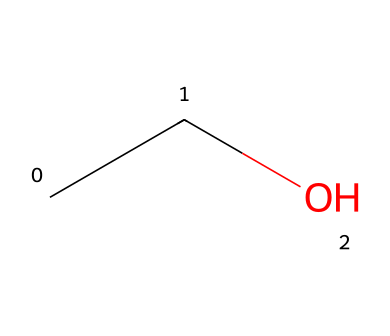What is the chemical name of the structure represented? The SMILES representation "CCO" indicates the presence of a two-carbon chain and a hydroxyl group, which defines the structure as ethanol.
Answer: ethanol How many carbon atoms are in the chemical structure? The SMILES representation "CCO" shows two 'C' symbols, indicating there are two carbon atoms present.
Answer: 2 What type of functional group is present in ethanol? An -OH group is indicated by the 'O' at the end of the SMILES notation "CCO", which identifies it as an alcohol.
Answer: alcohol How many hydrogen atoms are in the structure of ethanol? The two carbon atoms each bond to five hydrogen atoms, resulting in the total being 6 hydrogen atoms in "CCO".
Answer: 6 Is ethanol a non-electrolyte? Ethanol does not dissociate into ions in solution, confirming it as a non-electrolyte.
Answer: yes What is the total number of bonds in this molecule? In the chain "CCO", there are 5 total bonds: 1 bond between the first and second carbon, and 4 bonds between carbon and hydrogen, and the bond between oxygen and carbon, totaling 5.
Answer: 5 